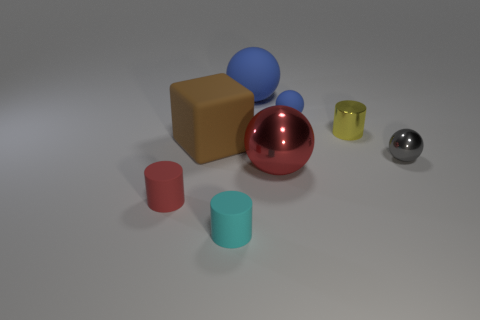Is there a shiny object that has the same size as the cyan rubber thing?
Make the answer very short. Yes. Does the big rubber ball have the same color as the shiny sphere that is to the right of the red shiny sphere?
Your response must be concise. No. How many gray things are on the right side of the tiny matte cylinder that is behind the tiny cyan rubber object?
Provide a succinct answer. 1. There is a large ball right of the blue rubber sphere behind the small blue matte object; what color is it?
Make the answer very short. Red. What is the object that is in front of the matte block and left of the cyan matte cylinder made of?
Provide a short and direct response. Rubber. Are there any small brown things that have the same shape as the cyan thing?
Give a very brief answer. No. Is the shape of the big rubber thing that is to the right of the cyan cylinder the same as  the small yellow metal thing?
Keep it short and to the point. No. How many large things are behind the brown rubber object and in front of the yellow thing?
Make the answer very short. 0. What is the shape of the red object that is left of the big metal object?
Your answer should be compact. Cylinder. How many cyan cylinders have the same material as the block?
Your answer should be very brief. 1. 